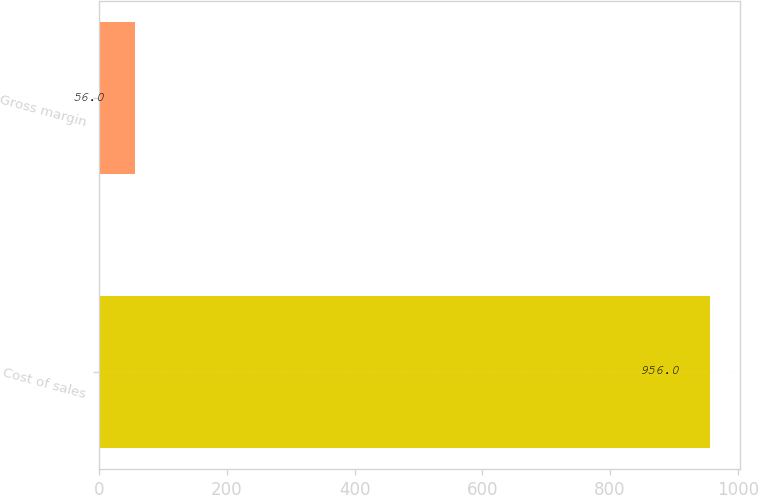Convert chart to OTSL. <chart><loc_0><loc_0><loc_500><loc_500><bar_chart><fcel>Cost of sales<fcel>Gross margin<nl><fcel>956<fcel>56<nl></chart> 